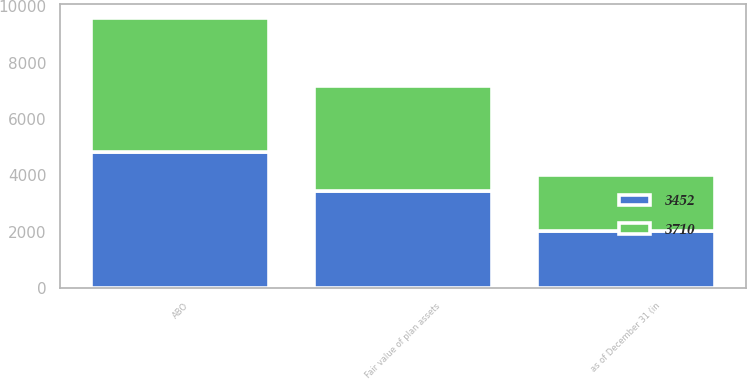Convert chart. <chart><loc_0><loc_0><loc_500><loc_500><stacked_bar_chart><ecel><fcel>as of December 31 (in<fcel>ABO<fcel>Fair value of plan assets<nl><fcel>3710<fcel>2013<fcel>4780<fcel>3710<nl><fcel>3452<fcel>2012<fcel>4816<fcel>3452<nl></chart> 